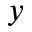<formula> <loc_0><loc_0><loc_500><loc_500>y</formula> 